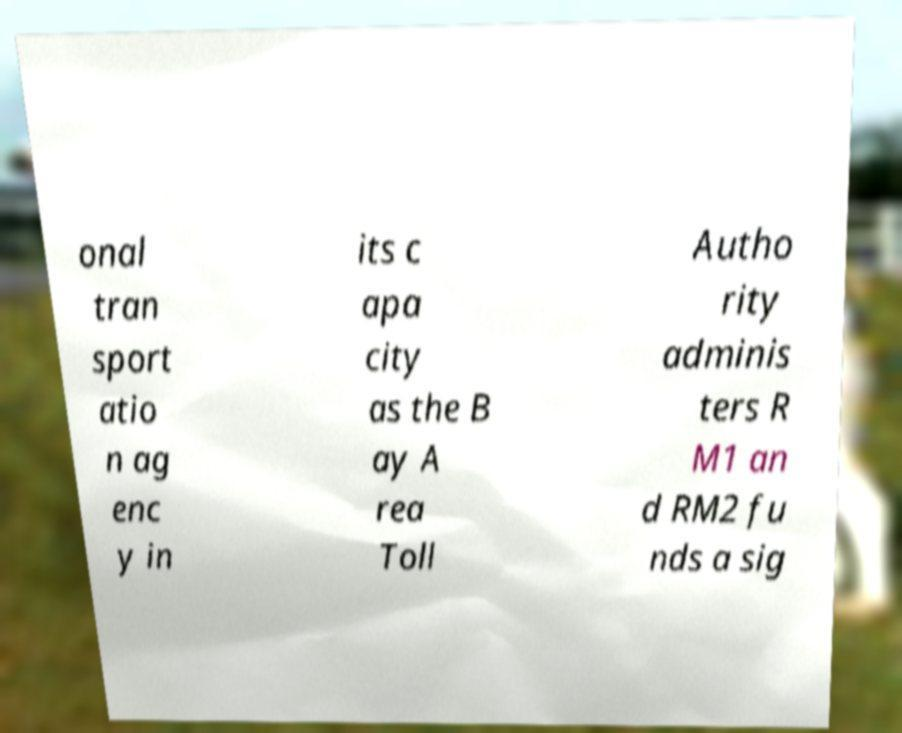I need the written content from this picture converted into text. Can you do that? onal tran sport atio n ag enc y in its c apa city as the B ay A rea Toll Autho rity adminis ters R M1 an d RM2 fu nds a sig 